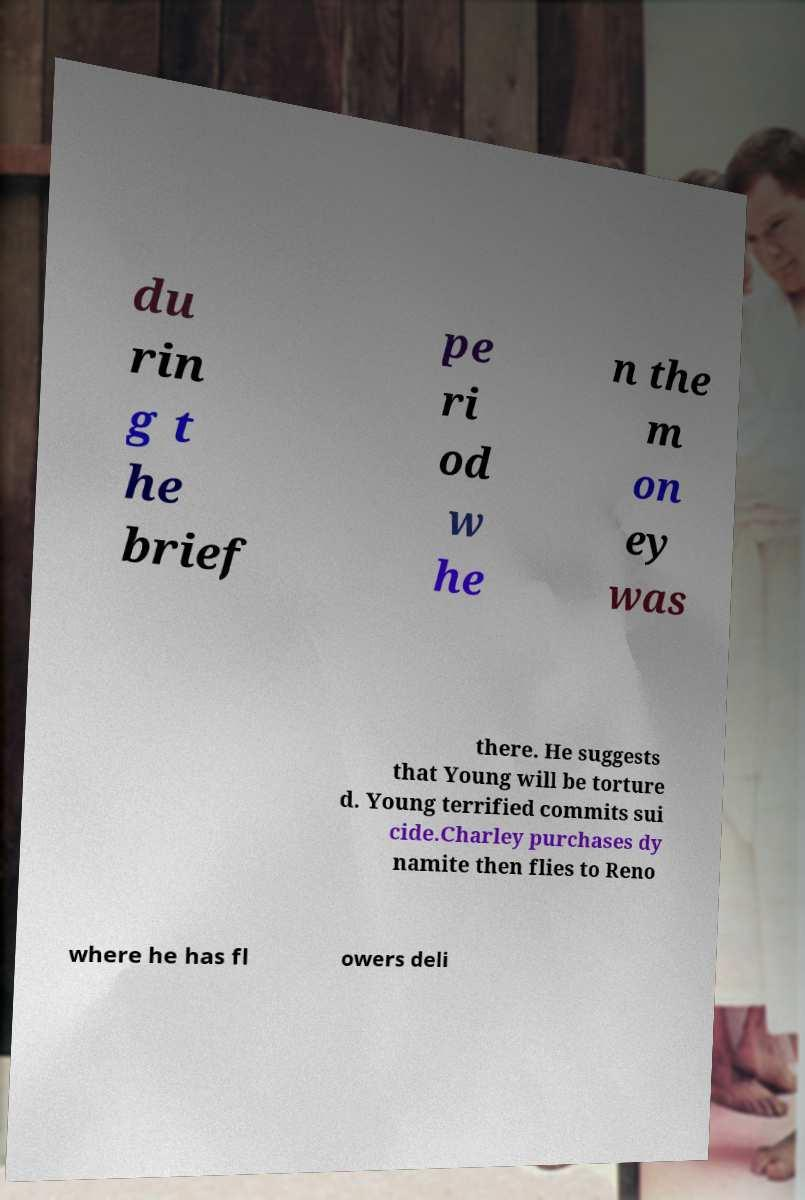Please read and relay the text visible in this image. What does it say? du rin g t he brief pe ri od w he n the m on ey was there. He suggests that Young will be torture d. Young terrified commits sui cide.Charley purchases dy namite then flies to Reno where he has fl owers deli 